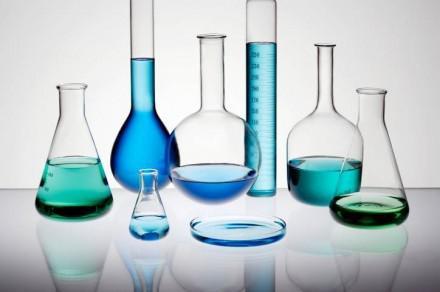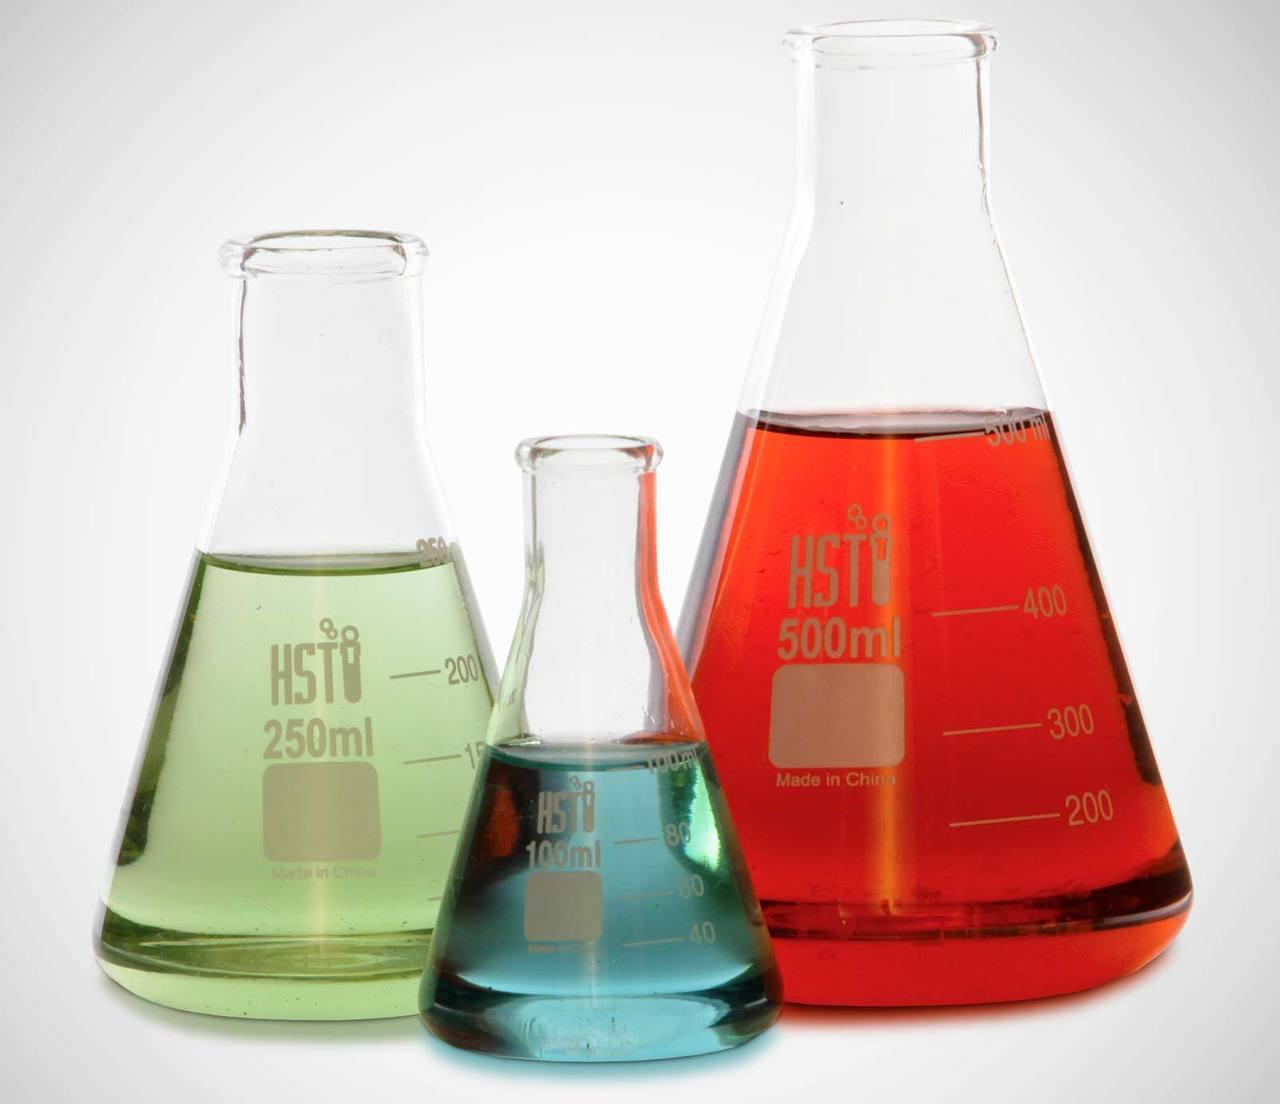The first image is the image on the left, the second image is the image on the right. Considering the images on both sides, is "All the containers have liquid in them." valid? Answer yes or no. Yes. The first image is the image on the left, the second image is the image on the right. Examine the images to the left and right. Is the description "In the image to the right, one of the flasks holds a yellow liquid." accurate? Answer yes or no. No. 